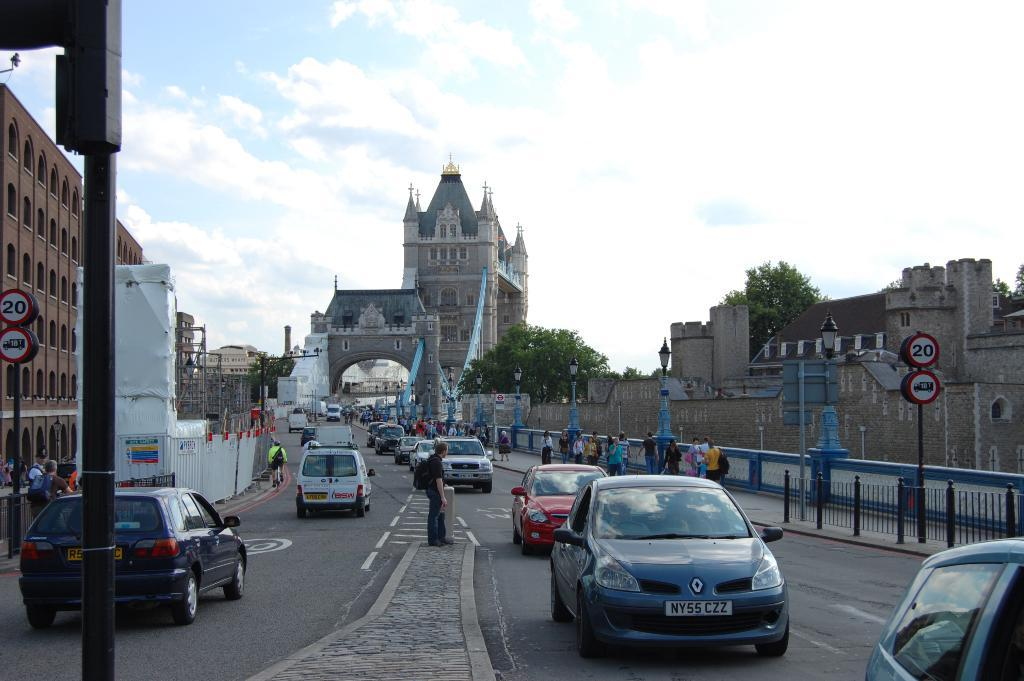What type of structure can be seen in the image? There is a bridge in the image. What else can be seen in the image besides the bridge? There are buildings, sign boards, vehicles, persons, a road, trees, fencing, and the sky visible in the image. What is the condition of the sky in the image? The sky is visible in the image, and clouds are present in the sky. What number is written on the skin of the person in the image? There is no mention of a number or skin in the provided facts, and therefore it cannot be determined from the image. 